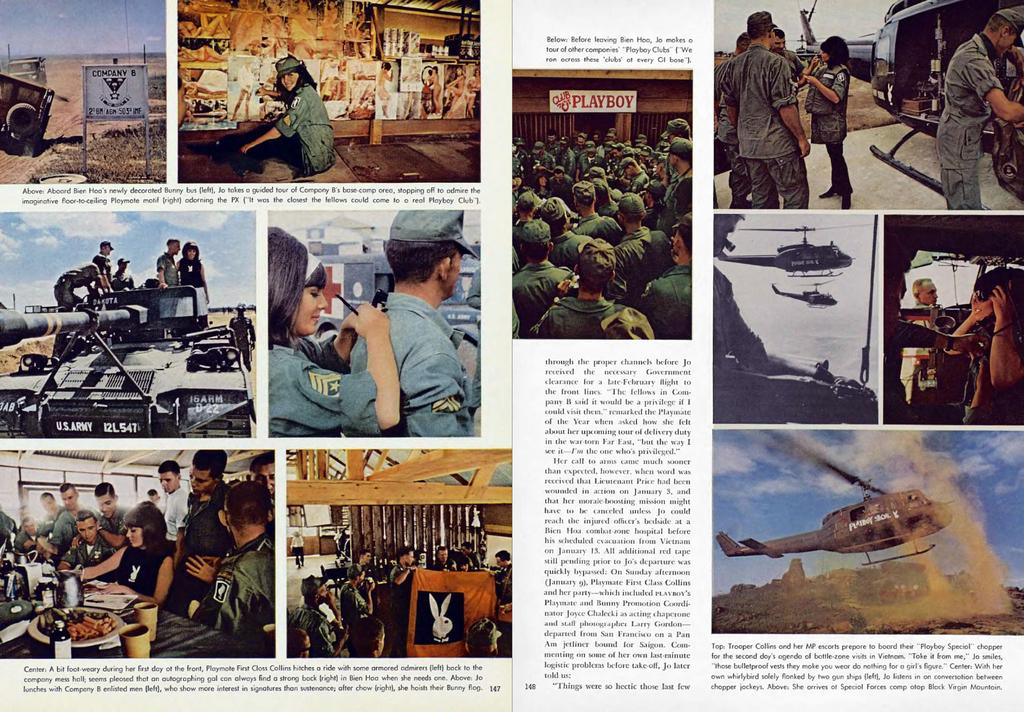<image>
Render a clear and concise summary of the photo. A magazine opened with advertisements including Playboy ans pictures. 